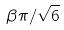Convert formula to latex. <formula><loc_0><loc_0><loc_500><loc_500>\beta \pi / \sqrt { 6 }</formula> 